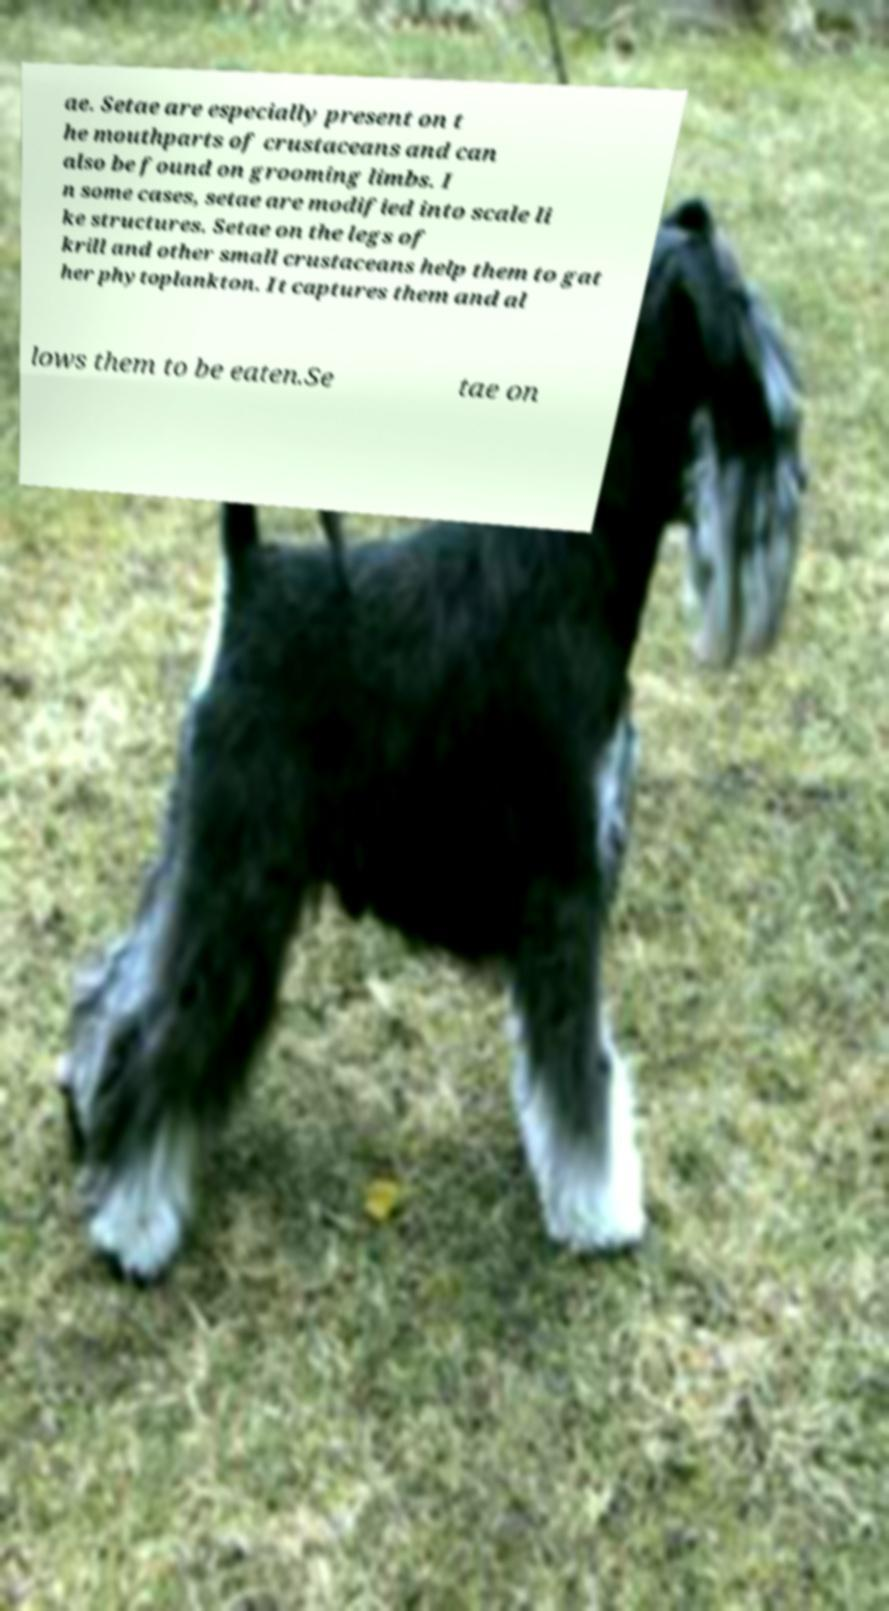There's text embedded in this image that I need extracted. Can you transcribe it verbatim? ae. Setae are especially present on t he mouthparts of crustaceans and can also be found on grooming limbs. I n some cases, setae are modified into scale li ke structures. Setae on the legs of krill and other small crustaceans help them to gat her phytoplankton. It captures them and al lows them to be eaten.Se tae on 